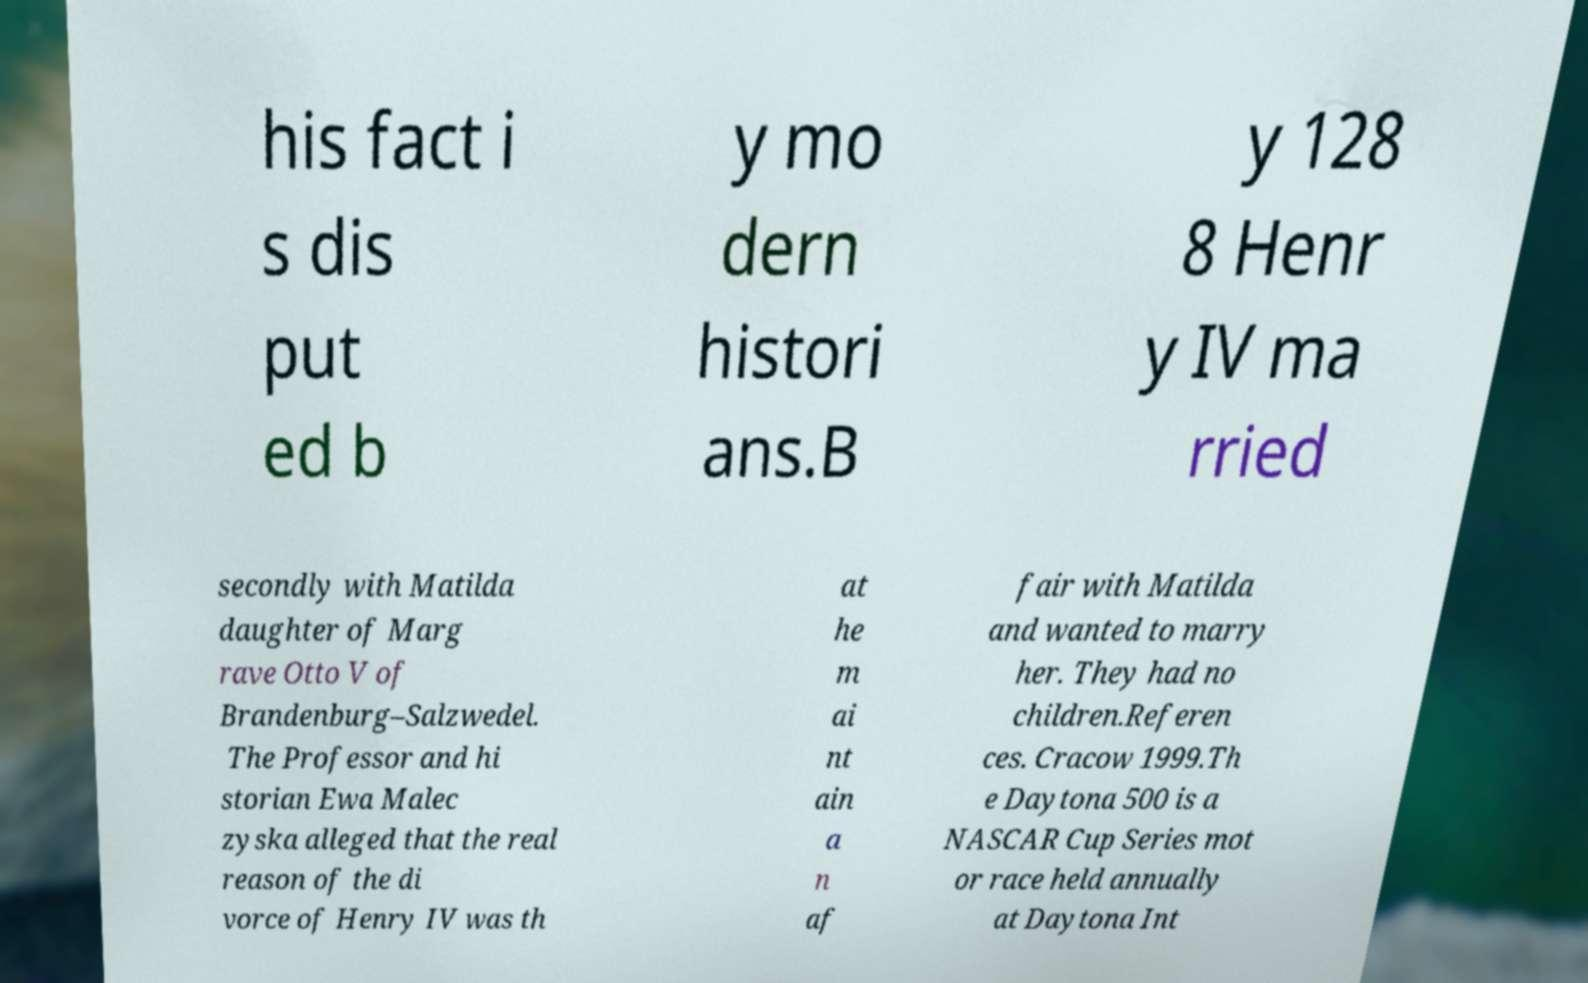What messages or text are displayed in this image? I need them in a readable, typed format. his fact i s dis put ed b y mo dern histori ans.B y 128 8 Henr y IV ma rried secondly with Matilda daughter of Marg rave Otto V of Brandenburg–Salzwedel. The Professor and hi storian Ewa Malec zyska alleged that the real reason of the di vorce of Henry IV was th at he m ai nt ain a n af fair with Matilda and wanted to marry her. They had no children.Referen ces. Cracow 1999.Th e Daytona 500 is a NASCAR Cup Series mot or race held annually at Daytona Int 